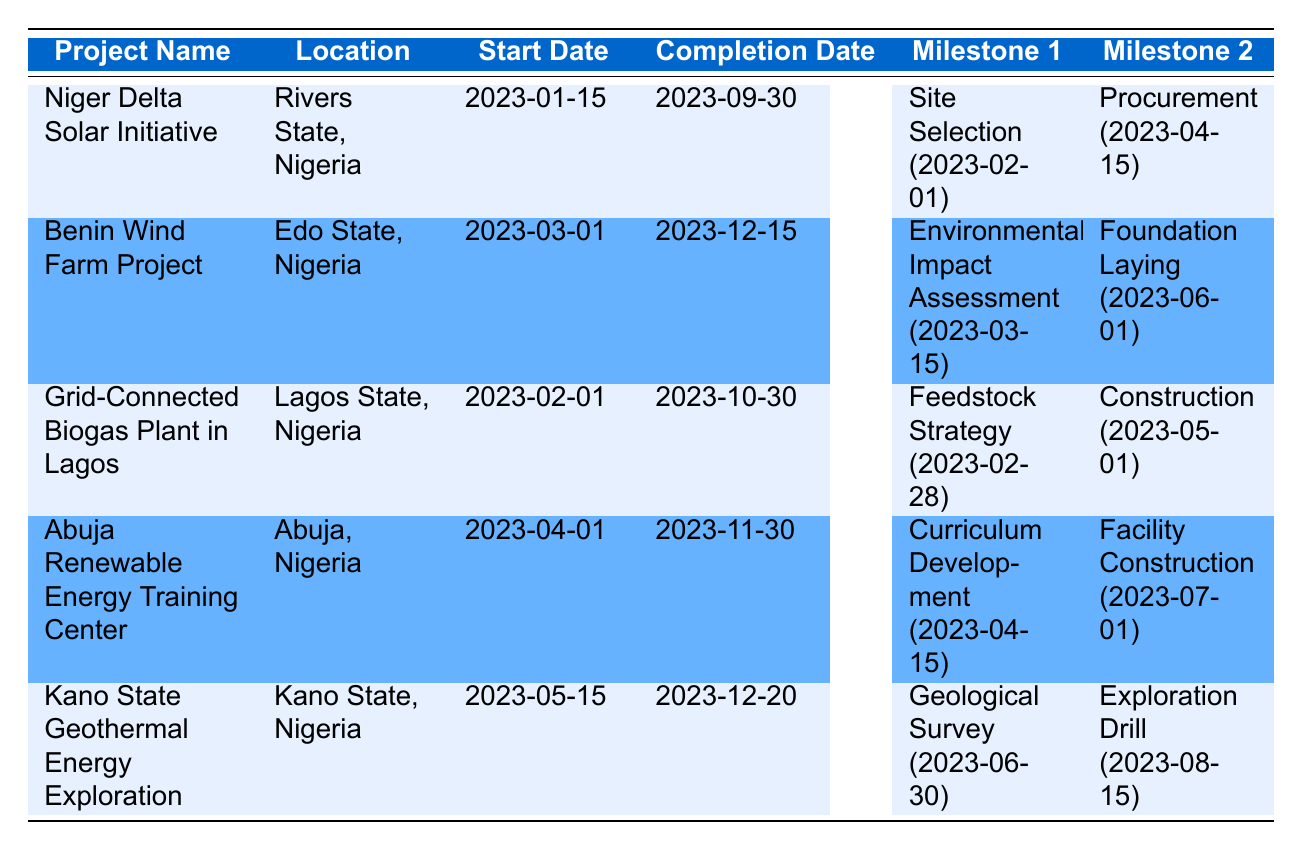What is the expected completion date of the Niger Delta Solar Initiative? The expected completion date for the Niger Delta Solar Initiative is listed in the table under the "Completion Date" column, which shows "2023-09-30."
Answer: 2023-09-30 Which project has its foundation laying scheduled for June 1, 2023? The table indicates the Benin Wind Farm Project has a milestone labeled "Foundation Laying for Turbines" set for June 1, 2023.
Answer: Benin Wind Farm Project What is the duration between the start date and expected completion date of the Abuja Renewable Energy Training Center? The start date is April 1, 2023, and the expected completion date is November 30, 2023. The duration can be calculated as follows: November 30 - April 1 = 7 months and 29 days.
Answer: 7 months and 29 days Is there a milestone related to biogas production scheduled before August 2023 in the Grid-Connected Biogas Plant in Lagos? The table shows that the milestones for the Grid-Connected Biogas Plant include "Feedstock Collection Strategy Finalized" on February 28, 2023, indicating there is at least one milestone before August.
Answer: Yes Which renewable energy project has the latest start date in 2023? By reviewing the "Start Date" column, the Kano State Geothermal Energy Exploration begins on May 15, 2023, which is the latest when compared to other projects.
Answer: Kano State Geothermal Energy Exploration What is the total number of milestones for the Grid-Connected Biogas Plant in Lagos? The table lists four milestones for the Grid-Connected Biogas Plant in Lagos. Therefore, to find the total, simply count the listed milestones, which are: Feedstock Collection Strategy Finalized, Construction of Digester and Generator, Biogas Production Begins, and Integration with Power Grid.
Answer: 4 When is the first training session for the Abuja Renewable Energy Training Center scheduled? The table indicates that the first training session is planned for November 1, 2023. This information can be found under the "Milestone" section for that project.
Answer: November 1, 2023 How many projects are expected to be completed in 2023 after July? Checking projects expected to be completed after July, the table reveals that the Benin Wind Farm Project (December 15) and the Kano State Geothermal Energy Exploration (December 20) both have completion dates after July, making the count 2 projects.
Answer: 2 projects What is the date for the Wind Turbine Installation in the Benin Wind Farm Project? The milestone "Wind Turbine Installation" is scheduled for September 1, 2023, as stated in the table for the Benin Wind Farm Project.
Answer: September 1, 2023 